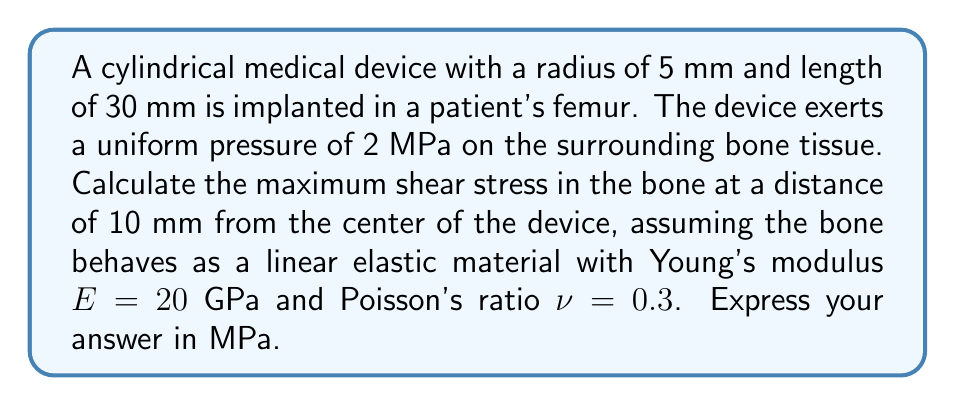Can you answer this question? To solve this problem, we'll follow these steps:

1) First, we need to determine the stress tensor components. In cylindrical coordinates (r, θ, z), due to symmetry, the stress tensor will have the form:

   $$\sigma = \begin{pmatrix}
   \sigma_r & 0 & 0 \\
   0 & \sigma_θ & 0 \\
   0 & 0 & \sigma_z
   \end{pmatrix}$$

2) For a thick-walled cylinder under internal pressure, the radial and tangential stresses are given by:

   $$\sigma_r = \frac{a^2p}{b^2-a^2}\left(1-\frac{b^2}{r^2}\right)$$
   $$\sigma_θ = \frac{a^2p}{b^2-a^2}\left(1+\frac{b^2}{r^2}\right)$$

   where a is the inner radius, b is the outer radius, p is the internal pressure, and r is the radial distance.

3) In our case, a = 5 mm, p = 2 MPa, and r = 10 mm. We can consider b to be much larger than a.

4) Substituting these values:

   $$\sigma_r = 2 \cdot \frac{5^2}{10^2}\left(1-\frac{b^2}{10^2}\right) \approx -0.5 \text{ MPa}$$
   $$\sigma_θ = 2 \cdot \frac{5^2}{10^2}\left(1+\frac{b^2}{10^2}\right) \approx 0.5 \text{ MPa}$$

5) The axial stress σz can be calculated using Hooke's law:

   $$\sigma_z = \nu(\sigma_r + \sigma_θ) = 0.3(-0.5 + 0.5) = 0 \text{ MPa}$$

6) The maximum shear stress is given by:

   $$\tau_{\text{max}} = \frac{1}{2}(\sigma_{\text{max}} - \sigma_{\text{min}})$$

   where σmax and σmin are the maximum and minimum principal stresses.

7) In this case, σmax = σθ = 0.5 MPa and σmin = σr = -0.5 MPa.

8) Therefore:

   $$\tau_{\text{max}} = \frac{1}{2}(0.5 - (-0.5)) = 0.5 \text{ MPa}$$
Answer: 0.5 MPa 